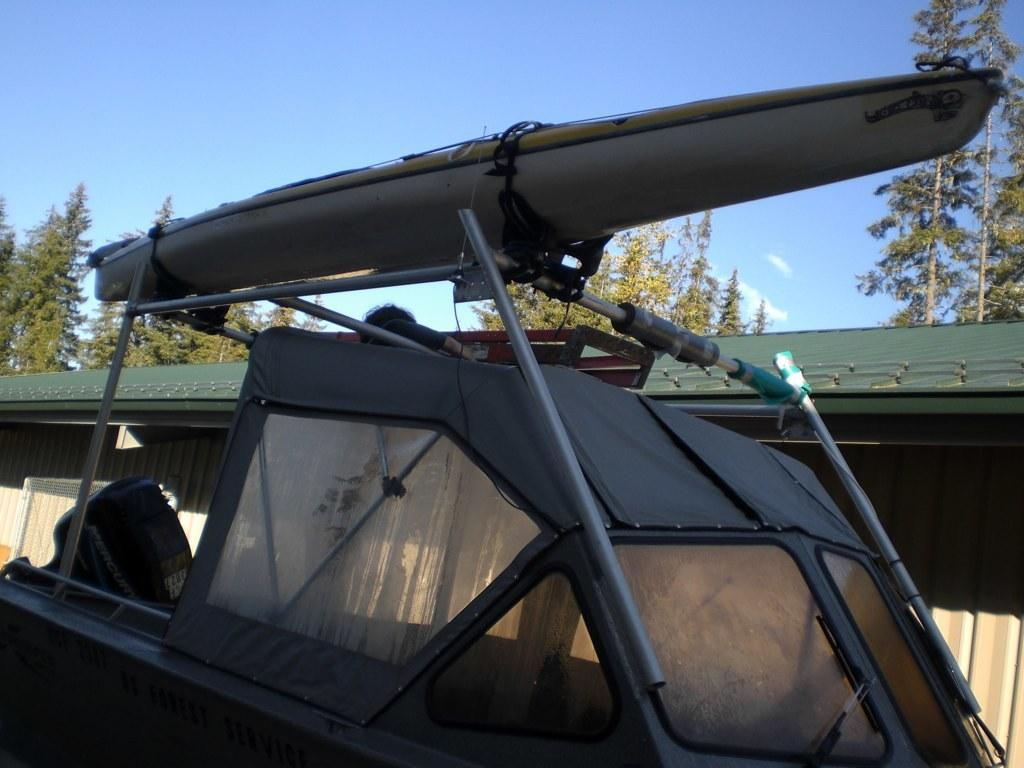What is the main subject of the image? There is a vehicle in the image. What specific feature can be seen on the vehicle? The vehicle has metal rods. What can be seen in the background of the image? There is a shed and trees in the background of the image. What is visible at the top of the image? The sky is visible at the top of the image. How does the vehicle express anger in the image? Vehicles do not express emotions like anger; they are inanimate objects. What is the name of the vehicle's son in the image? Vehicles do not have sons, as they are not living beings. 